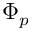Convert formula to latex. <formula><loc_0><loc_0><loc_500><loc_500>\Phi _ { p }</formula> 